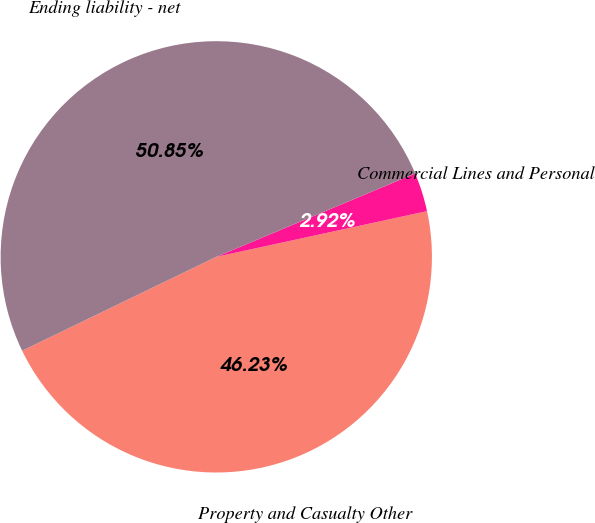<chart> <loc_0><loc_0><loc_500><loc_500><pie_chart><fcel>Property and Casualty Other<fcel>Commercial Lines and Personal<fcel>Ending liability - net<nl><fcel>46.23%<fcel>2.92%<fcel>50.85%<nl></chart> 